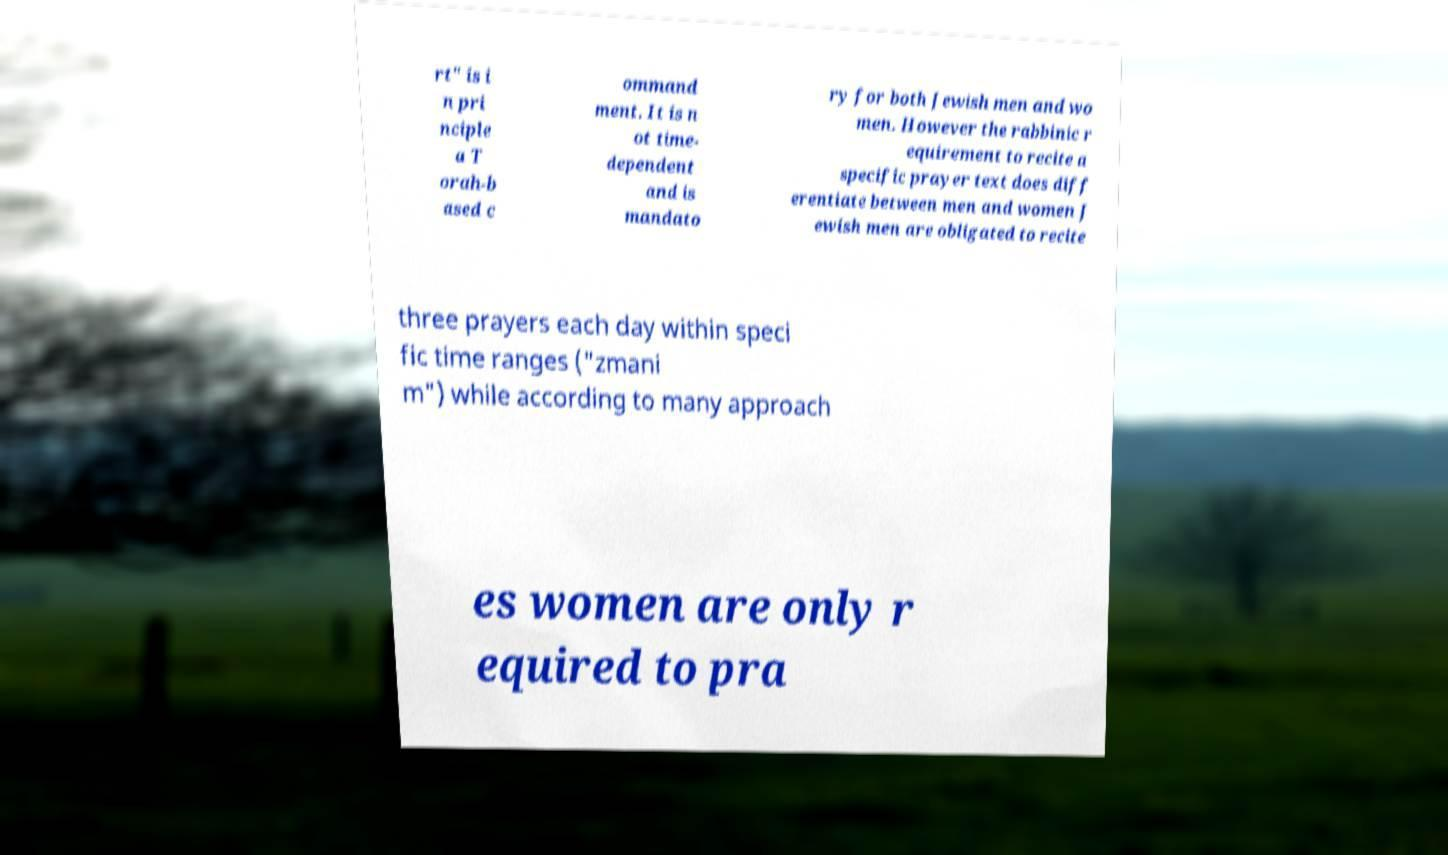There's text embedded in this image that I need extracted. Can you transcribe it verbatim? rt" is i n pri nciple a T orah-b ased c ommand ment. It is n ot time- dependent and is mandato ry for both Jewish men and wo men. However the rabbinic r equirement to recite a specific prayer text does diff erentiate between men and women J ewish men are obligated to recite three prayers each day within speci fic time ranges ("zmani m") while according to many approach es women are only r equired to pra 